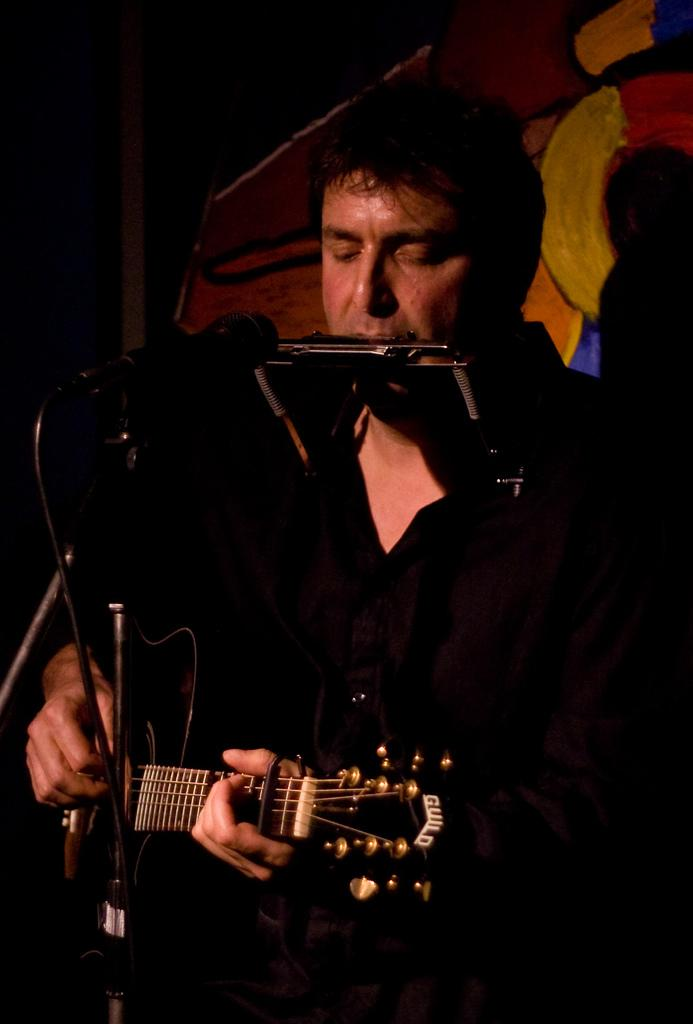What is the main subject of the image? There is a person in the image. What is the person doing in the image? The person is playing a guitar. What object is in front of the person? There is a microphone in front of the person. Are there any other people visible in the image? Yes, there is another person visible in the image. What type of prose is being recited by the person playing the guitar in the image? There is no indication in the image that the person is reciting any prose; they are playing a guitar. Can you tell me how many basketballs are visible in the image? There are no basketballs present in the image. 